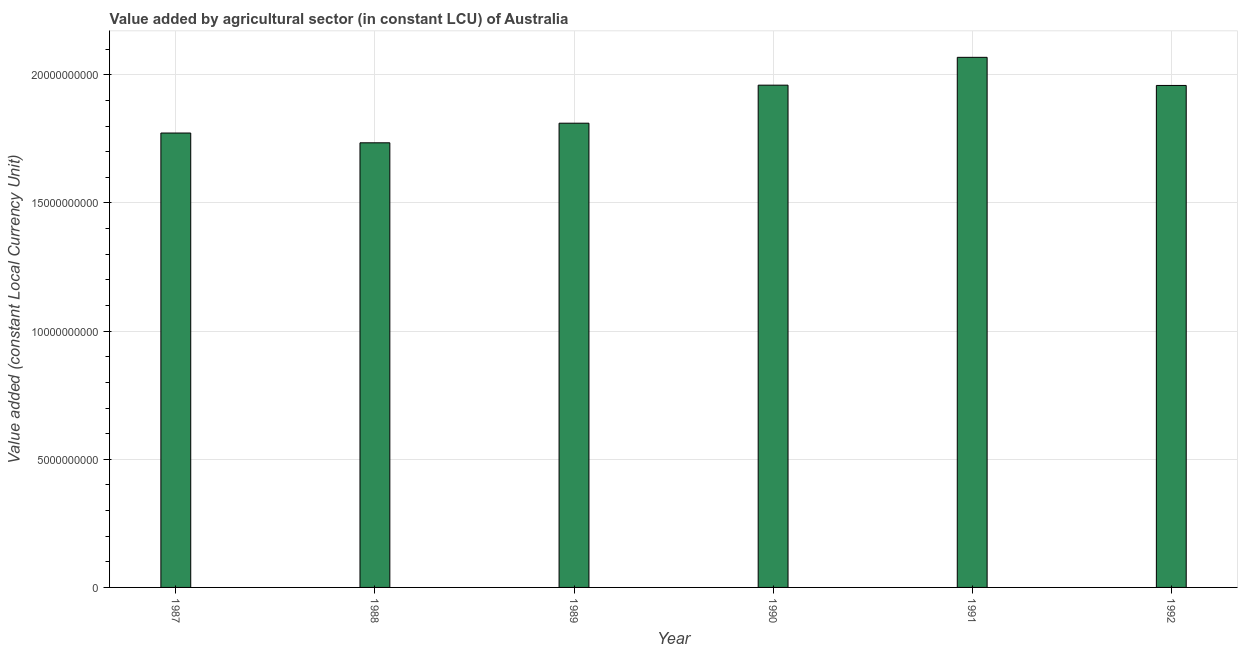What is the title of the graph?
Offer a terse response. Value added by agricultural sector (in constant LCU) of Australia. What is the label or title of the Y-axis?
Your answer should be compact. Value added (constant Local Currency Unit). What is the value added by agriculture sector in 1989?
Offer a terse response. 1.81e+1. Across all years, what is the maximum value added by agriculture sector?
Keep it short and to the point. 2.07e+1. Across all years, what is the minimum value added by agriculture sector?
Offer a very short reply. 1.73e+1. In which year was the value added by agriculture sector maximum?
Make the answer very short. 1991. What is the sum of the value added by agriculture sector?
Your response must be concise. 1.13e+11. What is the difference between the value added by agriculture sector in 1988 and 1991?
Provide a succinct answer. -3.34e+09. What is the average value added by agriculture sector per year?
Provide a succinct answer. 1.88e+1. What is the median value added by agriculture sector?
Your answer should be very brief. 1.88e+1. Do a majority of the years between 1990 and 1989 (inclusive) have value added by agriculture sector greater than 16000000000 LCU?
Offer a terse response. No. What is the ratio of the value added by agriculture sector in 1990 to that in 1991?
Offer a terse response. 0.95. Is the difference between the value added by agriculture sector in 1987 and 1991 greater than the difference between any two years?
Provide a succinct answer. No. What is the difference between the highest and the second highest value added by agriculture sector?
Keep it short and to the point. 1.09e+09. What is the difference between the highest and the lowest value added by agriculture sector?
Offer a very short reply. 3.34e+09. How many bars are there?
Ensure brevity in your answer.  6. How many years are there in the graph?
Your answer should be compact. 6. Are the values on the major ticks of Y-axis written in scientific E-notation?
Ensure brevity in your answer.  No. What is the Value added (constant Local Currency Unit) in 1987?
Provide a short and direct response. 1.77e+1. What is the Value added (constant Local Currency Unit) of 1988?
Offer a terse response. 1.73e+1. What is the Value added (constant Local Currency Unit) in 1989?
Offer a very short reply. 1.81e+1. What is the Value added (constant Local Currency Unit) of 1990?
Make the answer very short. 1.96e+1. What is the Value added (constant Local Currency Unit) of 1991?
Provide a succinct answer. 2.07e+1. What is the Value added (constant Local Currency Unit) in 1992?
Give a very brief answer. 1.96e+1. What is the difference between the Value added (constant Local Currency Unit) in 1987 and 1988?
Provide a short and direct response. 3.82e+08. What is the difference between the Value added (constant Local Currency Unit) in 1987 and 1989?
Your response must be concise. -3.83e+08. What is the difference between the Value added (constant Local Currency Unit) in 1987 and 1990?
Offer a terse response. -1.87e+09. What is the difference between the Value added (constant Local Currency Unit) in 1987 and 1991?
Ensure brevity in your answer.  -2.95e+09. What is the difference between the Value added (constant Local Currency Unit) in 1987 and 1992?
Keep it short and to the point. -1.86e+09. What is the difference between the Value added (constant Local Currency Unit) in 1988 and 1989?
Ensure brevity in your answer.  -7.65e+08. What is the difference between the Value added (constant Local Currency Unit) in 1988 and 1990?
Provide a short and direct response. -2.25e+09. What is the difference between the Value added (constant Local Currency Unit) in 1988 and 1991?
Offer a very short reply. -3.34e+09. What is the difference between the Value added (constant Local Currency Unit) in 1988 and 1992?
Your response must be concise. -2.24e+09. What is the difference between the Value added (constant Local Currency Unit) in 1989 and 1990?
Give a very brief answer. -1.48e+09. What is the difference between the Value added (constant Local Currency Unit) in 1989 and 1991?
Give a very brief answer. -2.57e+09. What is the difference between the Value added (constant Local Currency Unit) in 1989 and 1992?
Your answer should be very brief. -1.47e+09. What is the difference between the Value added (constant Local Currency Unit) in 1990 and 1991?
Your answer should be very brief. -1.09e+09. What is the difference between the Value added (constant Local Currency Unit) in 1990 and 1992?
Your response must be concise. 1.10e+07. What is the difference between the Value added (constant Local Currency Unit) in 1991 and 1992?
Your answer should be compact. 1.10e+09. What is the ratio of the Value added (constant Local Currency Unit) in 1987 to that in 1988?
Your response must be concise. 1.02. What is the ratio of the Value added (constant Local Currency Unit) in 1987 to that in 1990?
Make the answer very short. 0.91. What is the ratio of the Value added (constant Local Currency Unit) in 1987 to that in 1991?
Ensure brevity in your answer.  0.86. What is the ratio of the Value added (constant Local Currency Unit) in 1987 to that in 1992?
Offer a very short reply. 0.91. What is the ratio of the Value added (constant Local Currency Unit) in 1988 to that in 1989?
Your answer should be compact. 0.96. What is the ratio of the Value added (constant Local Currency Unit) in 1988 to that in 1990?
Provide a short and direct response. 0.89. What is the ratio of the Value added (constant Local Currency Unit) in 1988 to that in 1991?
Provide a succinct answer. 0.84. What is the ratio of the Value added (constant Local Currency Unit) in 1988 to that in 1992?
Your answer should be very brief. 0.89. What is the ratio of the Value added (constant Local Currency Unit) in 1989 to that in 1990?
Give a very brief answer. 0.92. What is the ratio of the Value added (constant Local Currency Unit) in 1989 to that in 1991?
Make the answer very short. 0.88. What is the ratio of the Value added (constant Local Currency Unit) in 1989 to that in 1992?
Keep it short and to the point. 0.93. What is the ratio of the Value added (constant Local Currency Unit) in 1990 to that in 1991?
Make the answer very short. 0.95. What is the ratio of the Value added (constant Local Currency Unit) in 1991 to that in 1992?
Keep it short and to the point. 1.06. 